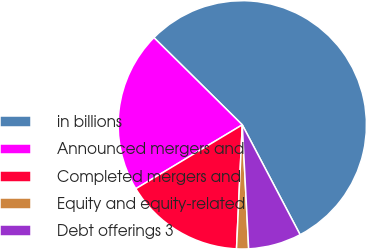Convert chart. <chart><loc_0><loc_0><loc_500><loc_500><pie_chart><fcel>in billions<fcel>Announced mergers and<fcel>Completed mergers and<fcel>Equity and equity-related<fcel>Debt offerings 3<nl><fcel>54.9%<fcel>21.0%<fcel>15.66%<fcel>1.56%<fcel>6.89%<nl></chart> 